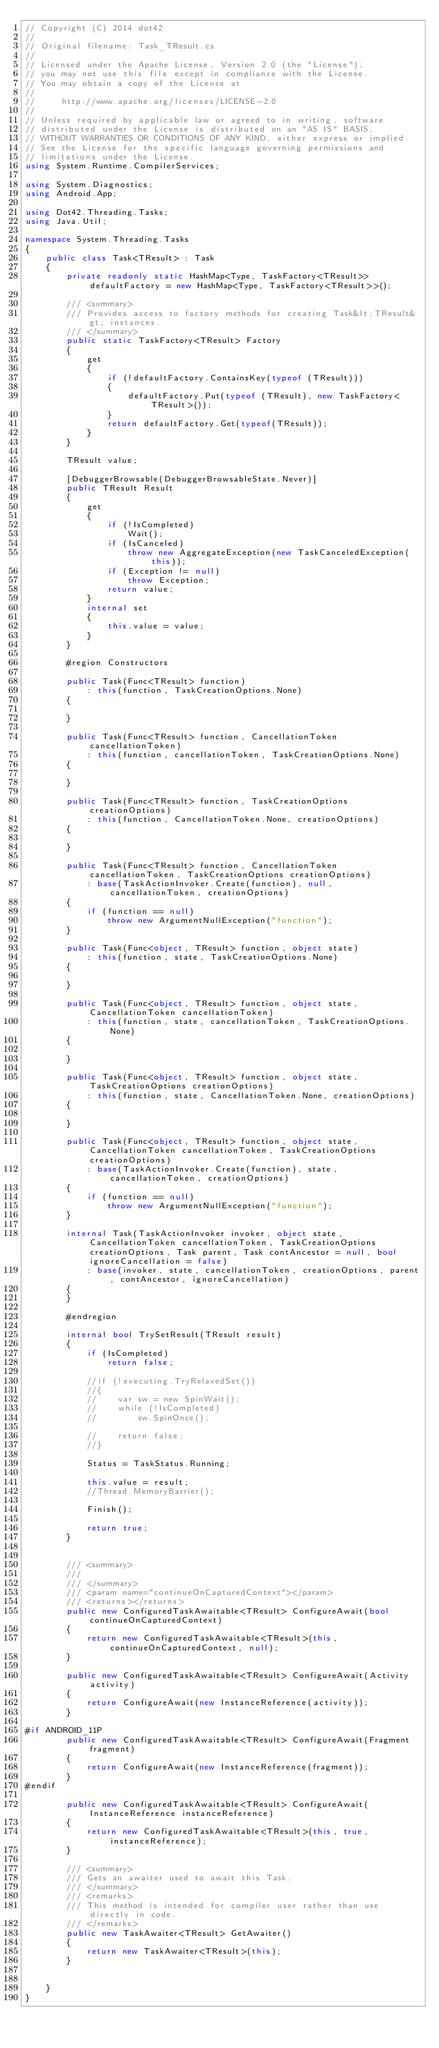Convert code to text. <code><loc_0><loc_0><loc_500><loc_500><_C#_>// Copyright (C) 2014 dot42
//
// Original filename: Task_TResult.cs
//
// Licensed under the Apache License, Version 2.0 (the "License");
// you may not use this file except in compliance with the License.
// You may obtain a copy of the License at
// 
//     http://www.apache.org/licenses/LICENSE-2.0
// 
// Unless required by applicable law or agreed to in writing, software
// distributed under the License is distributed on an "AS IS" BASIS,
// WITHOUT WARRANTIES OR CONDITIONS OF ANY KIND, either express or implied.
// See the License for the specific language governing permissions and
// limitations under the License.
using System.Runtime.CompilerServices;

using System.Diagnostics;
using Android.App;

using Dot42.Threading.Tasks;
using Java.Util;

namespace System.Threading.Tasks
{
	public class Task<TResult> : Task
	{
        private readonly static HashMap<Type, TaskFactory<TResult>> defaultFactory = new HashMap<Type, TaskFactory<TResult>>();

        /// <summary>
        /// Provides access to factory methods for creating Task&lt;TResult&gt; instances.
        /// </summary>
        public static TaskFactory<TResult> Factory
        {
            get
            {
                if (!defaultFactory.ContainsKey(typeof (TResult)))
                {
                    defaultFactory.Put(typeof (TResult), new TaskFactory<TResult>());
                }
                return defaultFactory.Get(typeof(TResult));
            }
        }

        TResult value;

        [DebuggerBrowsable(DebuggerBrowsableState.Never)]
        public TResult Result
        {
            get
            {
                if (!IsCompleted)
                    Wait();
                if (IsCanceled)
                    throw new AggregateException(new TaskCanceledException(this));
                if (Exception != null)
                    throw Exception;
                return value;
            }
            internal set
            {
                this.value = value;
            }
        }

        #region Constructors

        public Task(Func<TResult> function)
            : this(function, TaskCreationOptions.None)
        {

        }

        public Task(Func<TResult> function, CancellationToken cancellationToken)
            : this(function, cancellationToken, TaskCreationOptions.None)
        {

        }

        public Task(Func<TResult> function, TaskCreationOptions creationOptions)
            : this(function, CancellationToken.None, creationOptions)
        {

        }

        public Task(Func<TResult> function, CancellationToken cancellationToken, TaskCreationOptions creationOptions)
            : base(TaskActionInvoker.Create(function), null, cancellationToken, creationOptions)
        {
            if (function == null)
                throw new ArgumentNullException("function");
        }

        public Task(Func<object, TResult> function, object state)
            : this(function, state, TaskCreationOptions.None)
        {

        }

        public Task(Func<object, TResult> function, object state, CancellationToken cancellationToken)
            : this(function, state, cancellationToken, TaskCreationOptions.None)
        {

        }

        public Task(Func<object, TResult> function, object state, TaskCreationOptions creationOptions)
            : this(function, state, CancellationToken.None, creationOptions)
        {

        }

        public Task(Func<object, TResult> function, object state, CancellationToken cancellationToken, TaskCreationOptions creationOptions)
            : base(TaskActionInvoker.Create(function), state, cancellationToken, creationOptions)
        {
            if (function == null)
                throw new ArgumentNullException("function");
        }

        internal Task(TaskActionInvoker invoker, object state, CancellationToken cancellationToken, TaskCreationOptions creationOptions, Task parent, Task contAncestor = null, bool ignoreCancellation = false)
            : base(invoker, state, cancellationToken, creationOptions, parent, contAncestor, ignoreCancellation)
        {
        }

        #endregion

        internal bool TrySetResult(TResult result)
        {
            if (IsCompleted)
                return false;

            //if (!executing.TryRelaxedSet())
            //{
            //    var sw = new SpinWait();
            //    while (!IsCompleted)
            //        sw.SpinOnce();

            //    return false;
            //}

            Status = TaskStatus.Running;

            this.value = result;
            //Thread.MemoryBarrier();

            Finish();

            return true;
        }


        /// <summary>
        /// 
        /// </summary>
        /// <param name="continueOnCapturedContext"></param>
        /// <returns></returns>
        public new ConfiguredTaskAwaitable<TResult> ConfigureAwait(bool continueOnCapturedContext)
        {
            return new ConfiguredTaskAwaitable<TResult>(this, continueOnCapturedContext, null);
        }

        public new ConfiguredTaskAwaitable<TResult> ConfigureAwait(Activity activity)
        {
            return ConfigureAwait(new InstanceReference(activity));
        }

#if ANDROID_11P
        public new ConfiguredTaskAwaitable<TResult> ConfigureAwait(Fragment fragment)
        {
            return ConfigureAwait(new InstanceReference(fragment));
        }
#endif

        public new ConfiguredTaskAwaitable<TResult> ConfigureAwait(InstanceReference instanceReference)
        {
            return new ConfiguredTaskAwaitable<TResult>(this, true, instanceReference);
        }

        /// <summary>
        /// Gets an awaiter used to await this Task.
        /// </summary>
        /// <remarks>
        /// This method is intended for compiler user rather than use directly in code.
        /// </remarks>
        public new TaskAwaiter<TResult> GetAwaiter()
        {
            return new TaskAwaiter<TResult>(this);
        }


    }
}

</code> 